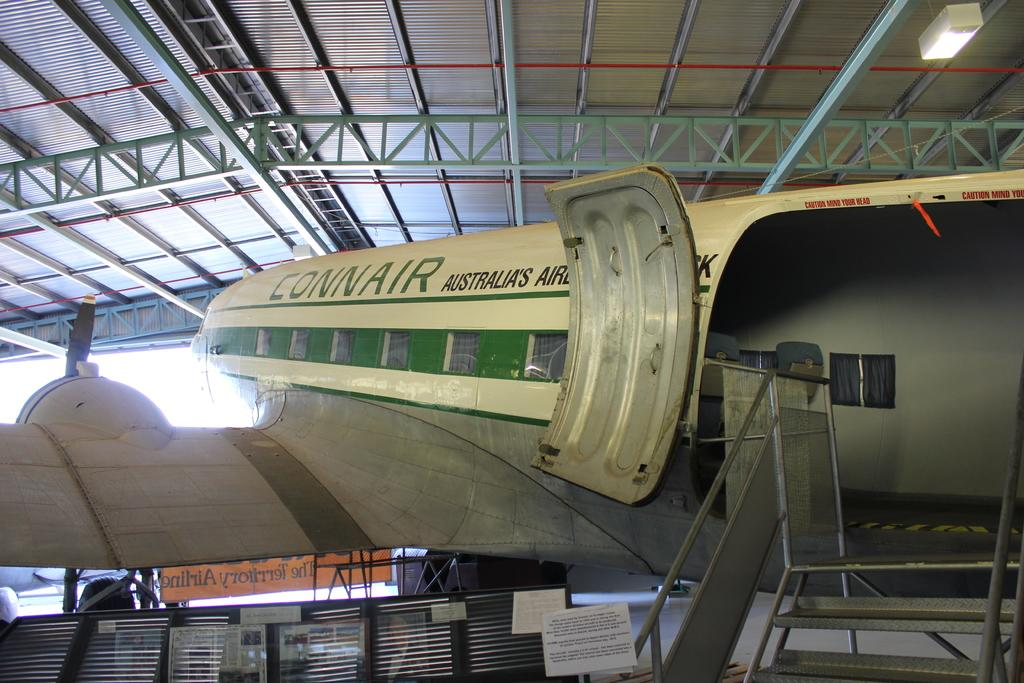<image>
Give a short and clear explanation of the subsequent image. An Australian Connair airplane sits in a hanger. 